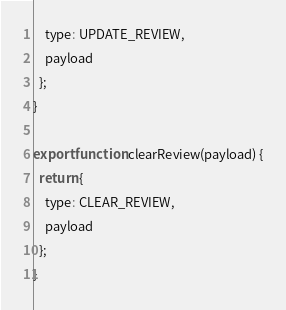<code> <loc_0><loc_0><loc_500><loc_500><_JavaScript_>    type: UPDATE_REVIEW,
    payload
  };
}

export function clearReview(payload) {
  return {
    type: CLEAR_REVIEW,
    payload
  };
}</code> 